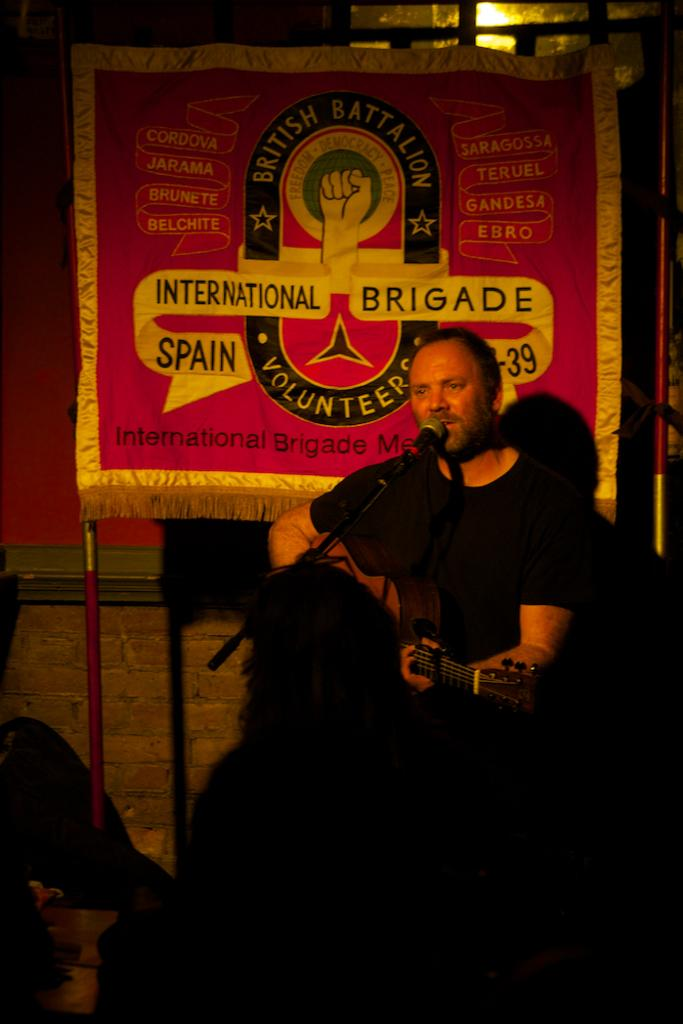What is the man in the image doing? The man is sitting and playing a guitar. What object is in front of the man? There is a microphone and a stand in front of the man. What can be seen in the background of the image? There is a board in the background of the image. How many gates are present in the image? There are no gates present in the image. What type of lip product is the man using in the image? The man is not using any lip product in the image. 